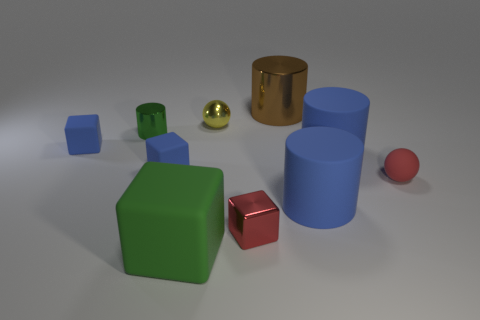There is a big cylinder that is in front of the tiny red matte thing; what material is it?
Provide a succinct answer. Rubber. There is a small metallic object to the left of the big green matte block; does it have the same shape as the tiny red object right of the large brown object?
Make the answer very short. No. Are there an equal number of blocks to the right of the tiny green cylinder and big blue cylinders?
Provide a short and direct response. No. How many tiny balls have the same material as the green block?
Keep it short and to the point. 1. The large cylinder that is the same material as the tiny red cube is what color?
Keep it short and to the point. Brown. There is a red rubber object; does it have the same size as the metal thing left of the tiny yellow object?
Offer a terse response. Yes. What shape is the green rubber thing?
Make the answer very short. Cube. How many small shiny things are the same color as the metal block?
Offer a terse response. 0. There is a small matte thing that is the same shape as the tiny yellow metallic object; what is its color?
Provide a short and direct response. Red. What number of metallic things are behind the tiny sphere that is left of the big shiny cylinder?
Make the answer very short. 1. 